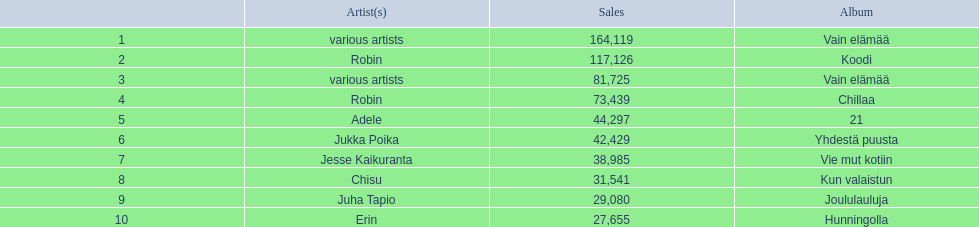Who is the artist for 21 album? Adele. Who is the artist for kun valaistun? Chisu. Which album had the same artist as chillaa? Koodi. 